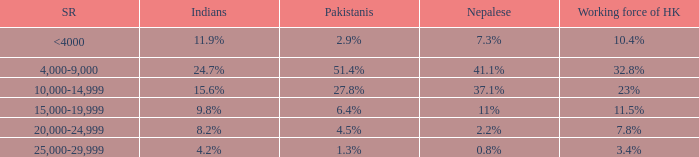Can you parse all the data within this table? {'header': ['SR', 'Indians', 'Pakistanis', 'Nepalese', 'Working force of HK'], 'rows': [['<4000', '11.9%', '2.9%', '7.3%', '10.4%'], ['4,000-9,000', '24.7%', '51.4%', '41.1%', '32.8%'], ['10,000-14,999', '15.6%', '27.8%', '37.1%', '23%'], ['15,000-19,999', '9.8%', '6.4%', '11%', '11.5%'], ['20,000-24,999', '8.2%', '4.5%', '2.2%', '7.8%'], ['25,000-29,999', '4.2%', '1.3%', '0.8%', '3.4%']]} If the nepalese is 37.1%, what is the working force of HK? 23%. 